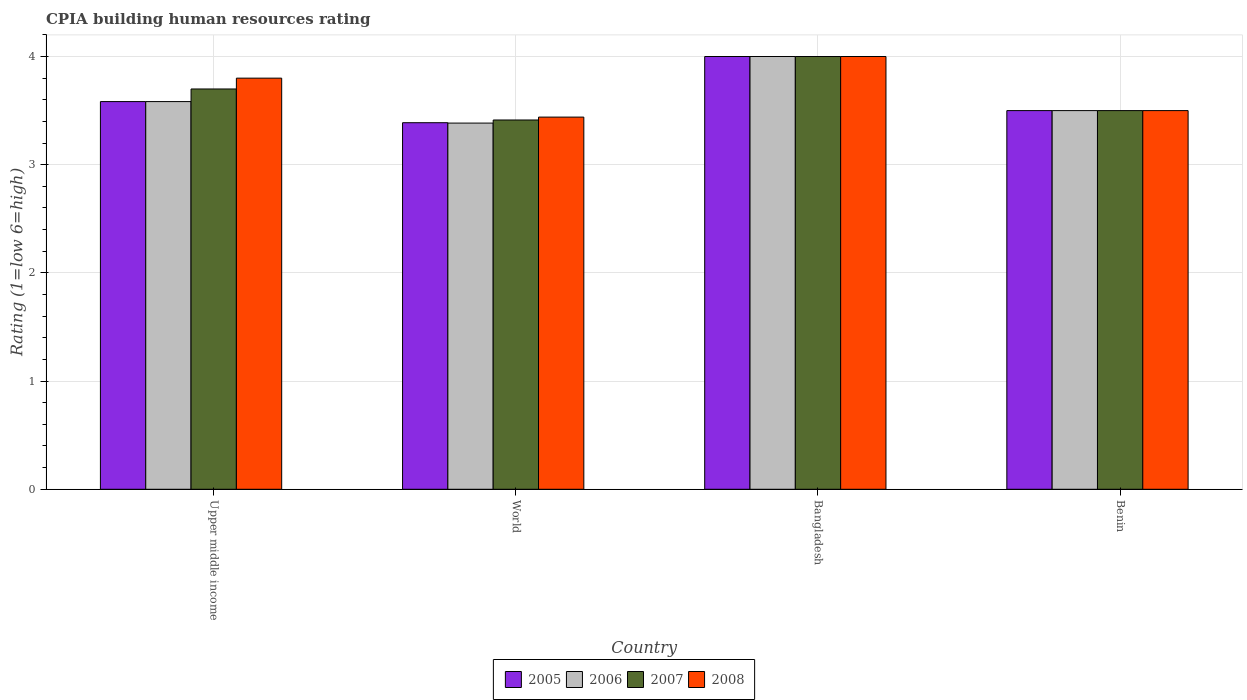How many different coloured bars are there?
Your answer should be very brief. 4. How many bars are there on the 4th tick from the left?
Provide a short and direct response. 4. How many bars are there on the 4th tick from the right?
Provide a succinct answer. 4. What is the label of the 1st group of bars from the left?
Your answer should be compact. Upper middle income. Across all countries, what is the maximum CPIA rating in 2007?
Provide a short and direct response. 4. Across all countries, what is the minimum CPIA rating in 2007?
Offer a terse response. 3.41. In which country was the CPIA rating in 2005 maximum?
Your answer should be very brief. Bangladesh. What is the total CPIA rating in 2008 in the graph?
Your answer should be compact. 14.74. What is the difference between the CPIA rating in 2007 in Bangladesh and that in World?
Ensure brevity in your answer.  0.59. What is the difference between the CPIA rating in 2007 in Upper middle income and the CPIA rating in 2005 in Bangladesh?
Make the answer very short. -0.3. What is the average CPIA rating in 2006 per country?
Give a very brief answer. 3.62. What is the ratio of the CPIA rating in 2005 in Benin to that in Upper middle income?
Provide a short and direct response. 0.98. Is the difference between the CPIA rating in 2006 in Benin and World greater than the difference between the CPIA rating in 2005 in Benin and World?
Offer a very short reply. Yes. What is the difference between the highest and the second highest CPIA rating in 2006?
Keep it short and to the point. -0.08. What is the difference between the highest and the lowest CPIA rating in 2008?
Your response must be concise. 0.56. What does the 1st bar from the left in World represents?
Your answer should be compact. 2005. What does the 4th bar from the right in World represents?
Make the answer very short. 2005. How many bars are there?
Offer a very short reply. 16. Are all the bars in the graph horizontal?
Give a very brief answer. No. How many countries are there in the graph?
Your answer should be very brief. 4. What is the difference between two consecutive major ticks on the Y-axis?
Offer a very short reply. 1. Does the graph contain grids?
Your answer should be compact. Yes. How many legend labels are there?
Provide a short and direct response. 4. How are the legend labels stacked?
Make the answer very short. Horizontal. What is the title of the graph?
Keep it short and to the point. CPIA building human resources rating. What is the label or title of the Y-axis?
Ensure brevity in your answer.  Rating (1=low 6=high). What is the Rating (1=low 6=high) in 2005 in Upper middle income?
Give a very brief answer. 3.58. What is the Rating (1=low 6=high) of 2006 in Upper middle income?
Offer a terse response. 3.58. What is the Rating (1=low 6=high) in 2005 in World?
Your answer should be compact. 3.39. What is the Rating (1=low 6=high) of 2006 in World?
Provide a short and direct response. 3.38. What is the Rating (1=low 6=high) in 2007 in World?
Your answer should be very brief. 3.41. What is the Rating (1=low 6=high) of 2008 in World?
Provide a short and direct response. 3.44. What is the Rating (1=low 6=high) of 2005 in Bangladesh?
Make the answer very short. 4. What is the Rating (1=low 6=high) of 2006 in Bangladesh?
Your answer should be very brief. 4. What is the Rating (1=low 6=high) of 2007 in Bangladesh?
Give a very brief answer. 4. What is the Rating (1=low 6=high) in 2005 in Benin?
Offer a terse response. 3.5. What is the Rating (1=low 6=high) of 2007 in Benin?
Your answer should be very brief. 3.5. What is the Rating (1=low 6=high) in 2008 in Benin?
Your answer should be very brief. 3.5. Across all countries, what is the maximum Rating (1=low 6=high) in 2005?
Make the answer very short. 4. Across all countries, what is the maximum Rating (1=low 6=high) of 2006?
Keep it short and to the point. 4. Across all countries, what is the maximum Rating (1=low 6=high) in 2007?
Provide a short and direct response. 4. Across all countries, what is the minimum Rating (1=low 6=high) in 2005?
Provide a succinct answer. 3.39. Across all countries, what is the minimum Rating (1=low 6=high) in 2006?
Keep it short and to the point. 3.38. Across all countries, what is the minimum Rating (1=low 6=high) of 2007?
Provide a short and direct response. 3.41. Across all countries, what is the minimum Rating (1=low 6=high) of 2008?
Keep it short and to the point. 3.44. What is the total Rating (1=low 6=high) of 2005 in the graph?
Make the answer very short. 14.47. What is the total Rating (1=low 6=high) of 2006 in the graph?
Offer a very short reply. 14.47. What is the total Rating (1=low 6=high) of 2007 in the graph?
Make the answer very short. 14.61. What is the total Rating (1=low 6=high) of 2008 in the graph?
Your answer should be compact. 14.74. What is the difference between the Rating (1=low 6=high) in 2005 in Upper middle income and that in World?
Offer a very short reply. 0.2. What is the difference between the Rating (1=low 6=high) in 2006 in Upper middle income and that in World?
Make the answer very short. 0.2. What is the difference between the Rating (1=low 6=high) of 2007 in Upper middle income and that in World?
Provide a succinct answer. 0.29. What is the difference between the Rating (1=low 6=high) in 2008 in Upper middle income and that in World?
Your answer should be very brief. 0.36. What is the difference between the Rating (1=low 6=high) in 2005 in Upper middle income and that in Bangladesh?
Provide a succinct answer. -0.42. What is the difference between the Rating (1=low 6=high) of 2006 in Upper middle income and that in Bangladesh?
Keep it short and to the point. -0.42. What is the difference between the Rating (1=low 6=high) in 2007 in Upper middle income and that in Bangladesh?
Your response must be concise. -0.3. What is the difference between the Rating (1=low 6=high) of 2005 in Upper middle income and that in Benin?
Provide a short and direct response. 0.08. What is the difference between the Rating (1=low 6=high) of 2006 in Upper middle income and that in Benin?
Offer a terse response. 0.08. What is the difference between the Rating (1=low 6=high) in 2005 in World and that in Bangladesh?
Offer a very short reply. -0.61. What is the difference between the Rating (1=low 6=high) in 2006 in World and that in Bangladesh?
Make the answer very short. -0.62. What is the difference between the Rating (1=low 6=high) in 2007 in World and that in Bangladesh?
Your answer should be very brief. -0.59. What is the difference between the Rating (1=low 6=high) of 2008 in World and that in Bangladesh?
Your answer should be compact. -0.56. What is the difference between the Rating (1=low 6=high) of 2005 in World and that in Benin?
Offer a terse response. -0.11. What is the difference between the Rating (1=low 6=high) in 2006 in World and that in Benin?
Make the answer very short. -0.12. What is the difference between the Rating (1=low 6=high) in 2007 in World and that in Benin?
Your response must be concise. -0.09. What is the difference between the Rating (1=low 6=high) in 2008 in World and that in Benin?
Keep it short and to the point. -0.06. What is the difference between the Rating (1=low 6=high) in 2005 in Bangladesh and that in Benin?
Your answer should be compact. 0.5. What is the difference between the Rating (1=low 6=high) of 2006 in Bangladesh and that in Benin?
Your response must be concise. 0.5. What is the difference between the Rating (1=low 6=high) in 2007 in Bangladesh and that in Benin?
Your response must be concise. 0.5. What is the difference between the Rating (1=low 6=high) of 2005 in Upper middle income and the Rating (1=low 6=high) of 2006 in World?
Offer a terse response. 0.2. What is the difference between the Rating (1=low 6=high) of 2005 in Upper middle income and the Rating (1=low 6=high) of 2007 in World?
Keep it short and to the point. 0.17. What is the difference between the Rating (1=low 6=high) of 2005 in Upper middle income and the Rating (1=low 6=high) of 2008 in World?
Make the answer very short. 0.14. What is the difference between the Rating (1=low 6=high) in 2006 in Upper middle income and the Rating (1=low 6=high) in 2007 in World?
Offer a terse response. 0.17. What is the difference between the Rating (1=low 6=high) in 2006 in Upper middle income and the Rating (1=low 6=high) in 2008 in World?
Provide a succinct answer. 0.14. What is the difference between the Rating (1=low 6=high) in 2007 in Upper middle income and the Rating (1=low 6=high) in 2008 in World?
Your answer should be compact. 0.26. What is the difference between the Rating (1=low 6=high) in 2005 in Upper middle income and the Rating (1=low 6=high) in 2006 in Bangladesh?
Your answer should be very brief. -0.42. What is the difference between the Rating (1=low 6=high) in 2005 in Upper middle income and the Rating (1=low 6=high) in 2007 in Bangladesh?
Your response must be concise. -0.42. What is the difference between the Rating (1=low 6=high) of 2005 in Upper middle income and the Rating (1=low 6=high) of 2008 in Bangladesh?
Give a very brief answer. -0.42. What is the difference between the Rating (1=low 6=high) in 2006 in Upper middle income and the Rating (1=low 6=high) in 2007 in Bangladesh?
Your answer should be compact. -0.42. What is the difference between the Rating (1=low 6=high) of 2006 in Upper middle income and the Rating (1=low 6=high) of 2008 in Bangladesh?
Ensure brevity in your answer.  -0.42. What is the difference between the Rating (1=low 6=high) of 2005 in Upper middle income and the Rating (1=low 6=high) of 2006 in Benin?
Provide a succinct answer. 0.08. What is the difference between the Rating (1=low 6=high) in 2005 in Upper middle income and the Rating (1=low 6=high) in 2007 in Benin?
Your answer should be compact. 0.08. What is the difference between the Rating (1=low 6=high) in 2005 in Upper middle income and the Rating (1=low 6=high) in 2008 in Benin?
Your response must be concise. 0.08. What is the difference between the Rating (1=low 6=high) in 2006 in Upper middle income and the Rating (1=low 6=high) in 2007 in Benin?
Provide a short and direct response. 0.08. What is the difference between the Rating (1=low 6=high) in 2006 in Upper middle income and the Rating (1=low 6=high) in 2008 in Benin?
Make the answer very short. 0.08. What is the difference between the Rating (1=low 6=high) in 2007 in Upper middle income and the Rating (1=low 6=high) in 2008 in Benin?
Your answer should be very brief. 0.2. What is the difference between the Rating (1=low 6=high) in 2005 in World and the Rating (1=low 6=high) in 2006 in Bangladesh?
Give a very brief answer. -0.61. What is the difference between the Rating (1=low 6=high) in 2005 in World and the Rating (1=low 6=high) in 2007 in Bangladesh?
Provide a succinct answer. -0.61. What is the difference between the Rating (1=low 6=high) of 2005 in World and the Rating (1=low 6=high) of 2008 in Bangladesh?
Your answer should be compact. -0.61. What is the difference between the Rating (1=low 6=high) of 2006 in World and the Rating (1=low 6=high) of 2007 in Bangladesh?
Offer a very short reply. -0.62. What is the difference between the Rating (1=low 6=high) of 2006 in World and the Rating (1=low 6=high) of 2008 in Bangladesh?
Provide a short and direct response. -0.62. What is the difference between the Rating (1=low 6=high) of 2007 in World and the Rating (1=low 6=high) of 2008 in Bangladesh?
Keep it short and to the point. -0.59. What is the difference between the Rating (1=low 6=high) in 2005 in World and the Rating (1=low 6=high) in 2006 in Benin?
Your answer should be very brief. -0.11. What is the difference between the Rating (1=low 6=high) of 2005 in World and the Rating (1=low 6=high) of 2007 in Benin?
Provide a succinct answer. -0.11. What is the difference between the Rating (1=low 6=high) in 2005 in World and the Rating (1=low 6=high) in 2008 in Benin?
Give a very brief answer. -0.11. What is the difference between the Rating (1=low 6=high) in 2006 in World and the Rating (1=low 6=high) in 2007 in Benin?
Your answer should be compact. -0.12. What is the difference between the Rating (1=low 6=high) of 2006 in World and the Rating (1=low 6=high) of 2008 in Benin?
Your response must be concise. -0.12. What is the difference between the Rating (1=low 6=high) in 2007 in World and the Rating (1=low 6=high) in 2008 in Benin?
Offer a terse response. -0.09. What is the average Rating (1=low 6=high) in 2005 per country?
Keep it short and to the point. 3.62. What is the average Rating (1=low 6=high) in 2006 per country?
Ensure brevity in your answer.  3.62. What is the average Rating (1=low 6=high) in 2007 per country?
Your response must be concise. 3.65. What is the average Rating (1=low 6=high) of 2008 per country?
Keep it short and to the point. 3.69. What is the difference between the Rating (1=low 6=high) of 2005 and Rating (1=low 6=high) of 2006 in Upper middle income?
Give a very brief answer. 0. What is the difference between the Rating (1=low 6=high) of 2005 and Rating (1=low 6=high) of 2007 in Upper middle income?
Ensure brevity in your answer.  -0.12. What is the difference between the Rating (1=low 6=high) of 2005 and Rating (1=low 6=high) of 2008 in Upper middle income?
Provide a succinct answer. -0.22. What is the difference between the Rating (1=low 6=high) in 2006 and Rating (1=low 6=high) in 2007 in Upper middle income?
Make the answer very short. -0.12. What is the difference between the Rating (1=low 6=high) of 2006 and Rating (1=low 6=high) of 2008 in Upper middle income?
Make the answer very short. -0.22. What is the difference between the Rating (1=low 6=high) of 2005 and Rating (1=low 6=high) of 2006 in World?
Provide a succinct answer. 0. What is the difference between the Rating (1=low 6=high) in 2005 and Rating (1=low 6=high) in 2007 in World?
Your answer should be compact. -0.03. What is the difference between the Rating (1=low 6=high) in 2005 and Rating (1=low 6=high) in 2008 in World?
Ensure brevity in your answer.  -0.05. What is the difference between the Rating (1=low 6=high) in 2006 and Rating (1=low 6=high) in 2007 in World?
Ensure brevity in your answer.  -0.03. What is the difference between the Rating (1=low 6=high) of 2006 and Rating (1=low 6=high) of 2008 in World?
Provide a succinct answer. -0.06. What is the difference between the Rating (1=low 6=high) of 2007 and Rating (1=low 6=high) of 2008 in World?
Give a very brief answer. -0.03. What is the difference between the Rating (1=low 6=high) of 2006 and Rating (1=low 6=high) of 2007 in Bangladesh?
Your response must be concise. 0. What is the difference between the Rating (1=low 6=high) of 2005 and Rating (1=low 6=high) of 2006 in Benin?
Make the answer very short. 0. What is the difference between the Rating (1=low 6=high) of 2006 and Rating (1=low 6=high) of 2007 in Benin?
Your response must be concise. 0. What is the ratio of the Rating (1=low 6=high) in 2005 in Upper middle income to that in World?
Ensure brevity in your answer.  1.06. What is the ratio of the Rating (1=low 6=high) in 2006 in Upper middle income to that in World?
Your response must be concise. 1.06. What is the ratio of the Rating (1=low 6=high) of 2007 in Upper middle income to that in World?
Offer a terse response. 1.08. What is the ratio of the Rating (1=low 6=high) of 2008 in Upper middle income to that in World?
Provide a succinct answer. 1.1. What is the ratio of the Rating (1=low 6=high) in 2005 in Upper middle income to that in Bangladesh?
Your response must be concise. 0.9. What is the ratio of the Rating (1=low 6=high) of 2006 in Upper middle income to that in Bangladesh?
Your answer should be very brief. 0.9. What is the ratio of the Rating (1=low 6=high) in 2007 in Upper middle income to that in Bangladesh?
Your answer should be compact. 0.93. What is the ratio of the Rating (1=low 6=high) in 2005 in Upper middle income to that in Benin?
Keep it short and to the point. 1.02. What is the ratio of the Rating (1=low 6=high) of 2006 in Upper middle income to that in Benin?
Give a very brief answer. 1.02. What is the ratio of the Rating (1=low 6=high) in 2007 in Upper middle income to that in Benin?
Your response must be concise. 1.06. What is the ratio of the Rating (1=low 6=high) in 2008 in Upper middle income to that in Benin?
Your response must be concise. 1.09. What is the ratio of the Rating (1=low 6=high) of 2005 in World to that in Bangladesh?
Your response must be concise. 0.85. What is the ratio of the Rating (1=low 6=high) in 2006 in World to that in Bangladesh?
Ensure brevity in your answer.  0.85. What is the ratio of the Rating (1=low 6=high) in 2007 in World to that in Bangladesh?
Your answer should be compact. 0.85. What is the ratio of the Rating (1=low 6=high) of 2008 in World to that in Bangladesh?
Make the answer very short. 0.86. What is the ratio of the Rating (1=low 6=high) of 2005 in World to that in Benin?
Your response must be concise. 0.97. What is the ratio of the Rating (1=low 6=high) of 2006 in World to that in Benin?
Provide a succinct answer. 0.97. What is the ratio of the Rating (1=low 6=high) in 2007 in World to that in Benin?
Make the answer very short. 0.98. What is the ratio of the Rating (1=low 6=high) of 2008 in World to that in Benin?
Provide a succinct answer. 0.98. What is the ratio of the Rating (1=low 6=high) of 2006 in Bangladesh to that in Benin?
Provide a short and direct response. 1.14. What is the difference between the highest and the second highest Rating (1=low 6=high) in 2005?
Offer a very short reply. 0.42. What is the difference between the highest and the second highest Rating (1=low 6=high) in 2006?
Offer a very short reply. 0.42. What is the difference between the highest and the second highest Rating (1=low 6=high) in 2007?
Provide a succinct answer. 0.3. What is the difference between the highest and the second highest Rating (1=low 6=high) in 2008?
Make the answer very short. 0.2. What is the difference between the highest and the lowest Rating (1=low 6=high) in 2005?
Your answer should be very brief. 0.61. What is the difference between the highest and the lowest Rating (1=low 6=high) in 2006?
Your response must be concise. 0.62. What is the difference between the highest and the lowest Rating (1=low 6=high) in 2007?
Your answer should be compact. 0.59. What is the difference between the highest and the lowest Rating (1=low 6=high) in 2008?
Offer a very short reply. 0.56. 